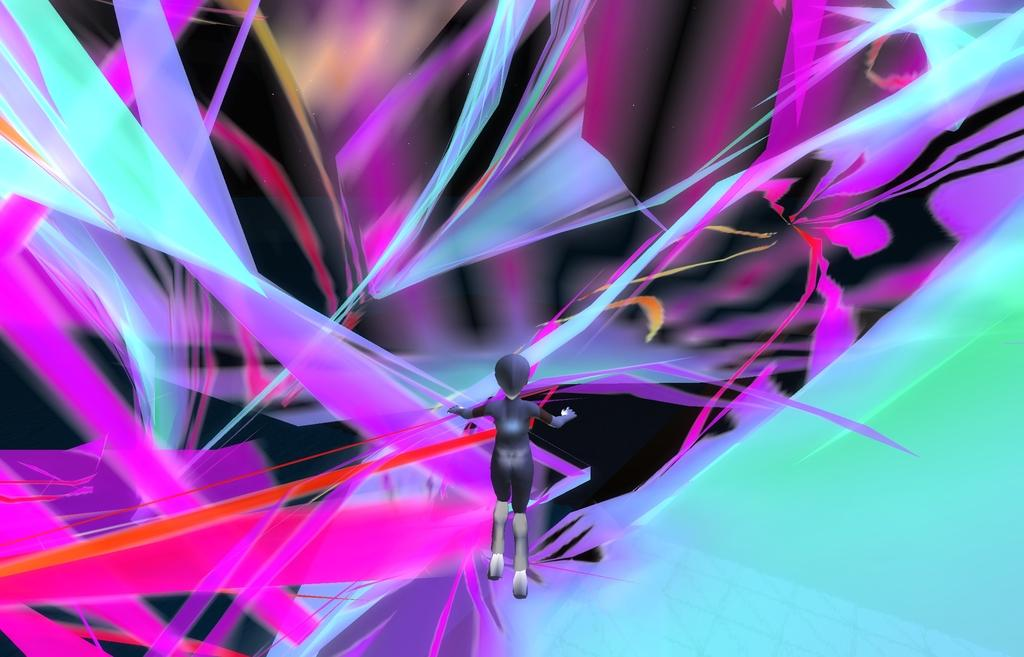What type of picture is depicted in the image? The image is an animation picture. What stage of development is the animation at in the image? The provided facts do not give any information about the development stage of the animation, so it cannot be determined from the image. 